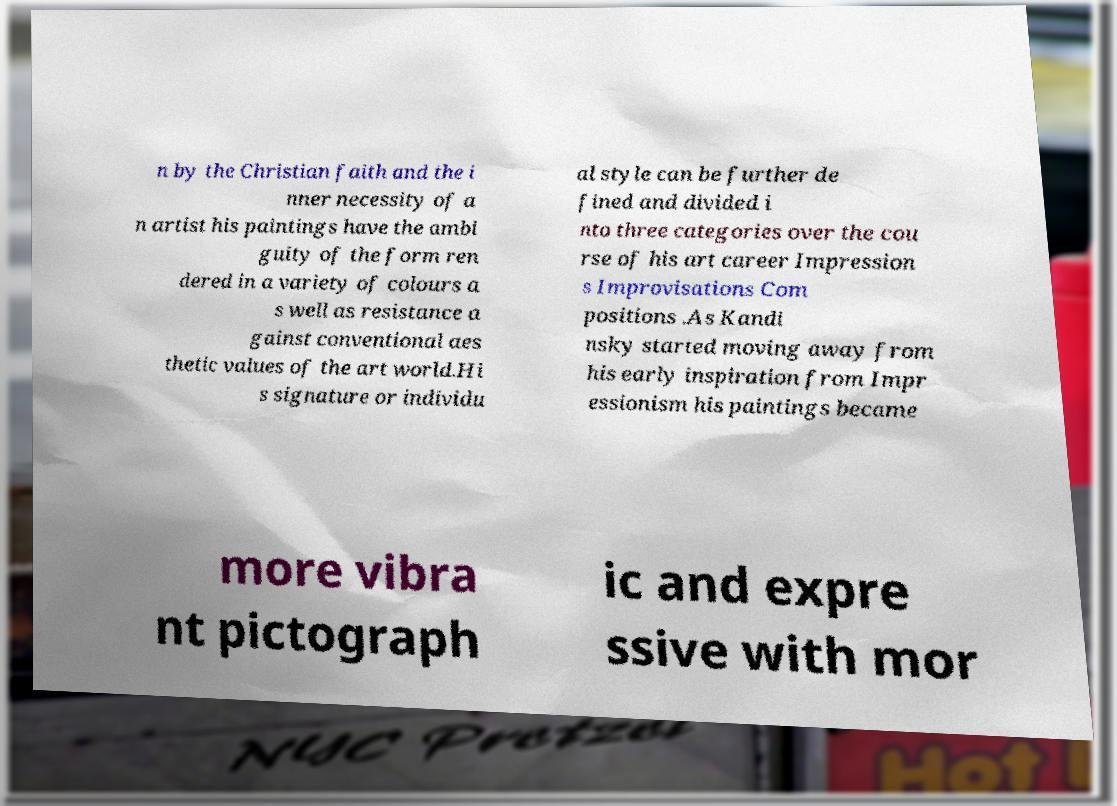Please identify and transcribe the text found in this image. n by the Christian faith and the i nner necessity of a n artist his paintings have the ambi guity of the form ren dered in a variety of colours a s well as resistance a gainst conventional aes thetic values of the art world.Hi s signature or individu al style can be further de fined and divided i nto three categories over the cou rse of his art career Impression s Improvisations Com positions .As Kandi nsky started moving away from his early inspiration from Impr essionism his paintings became more vibra nt pictograph ic and expre ssive with mor 